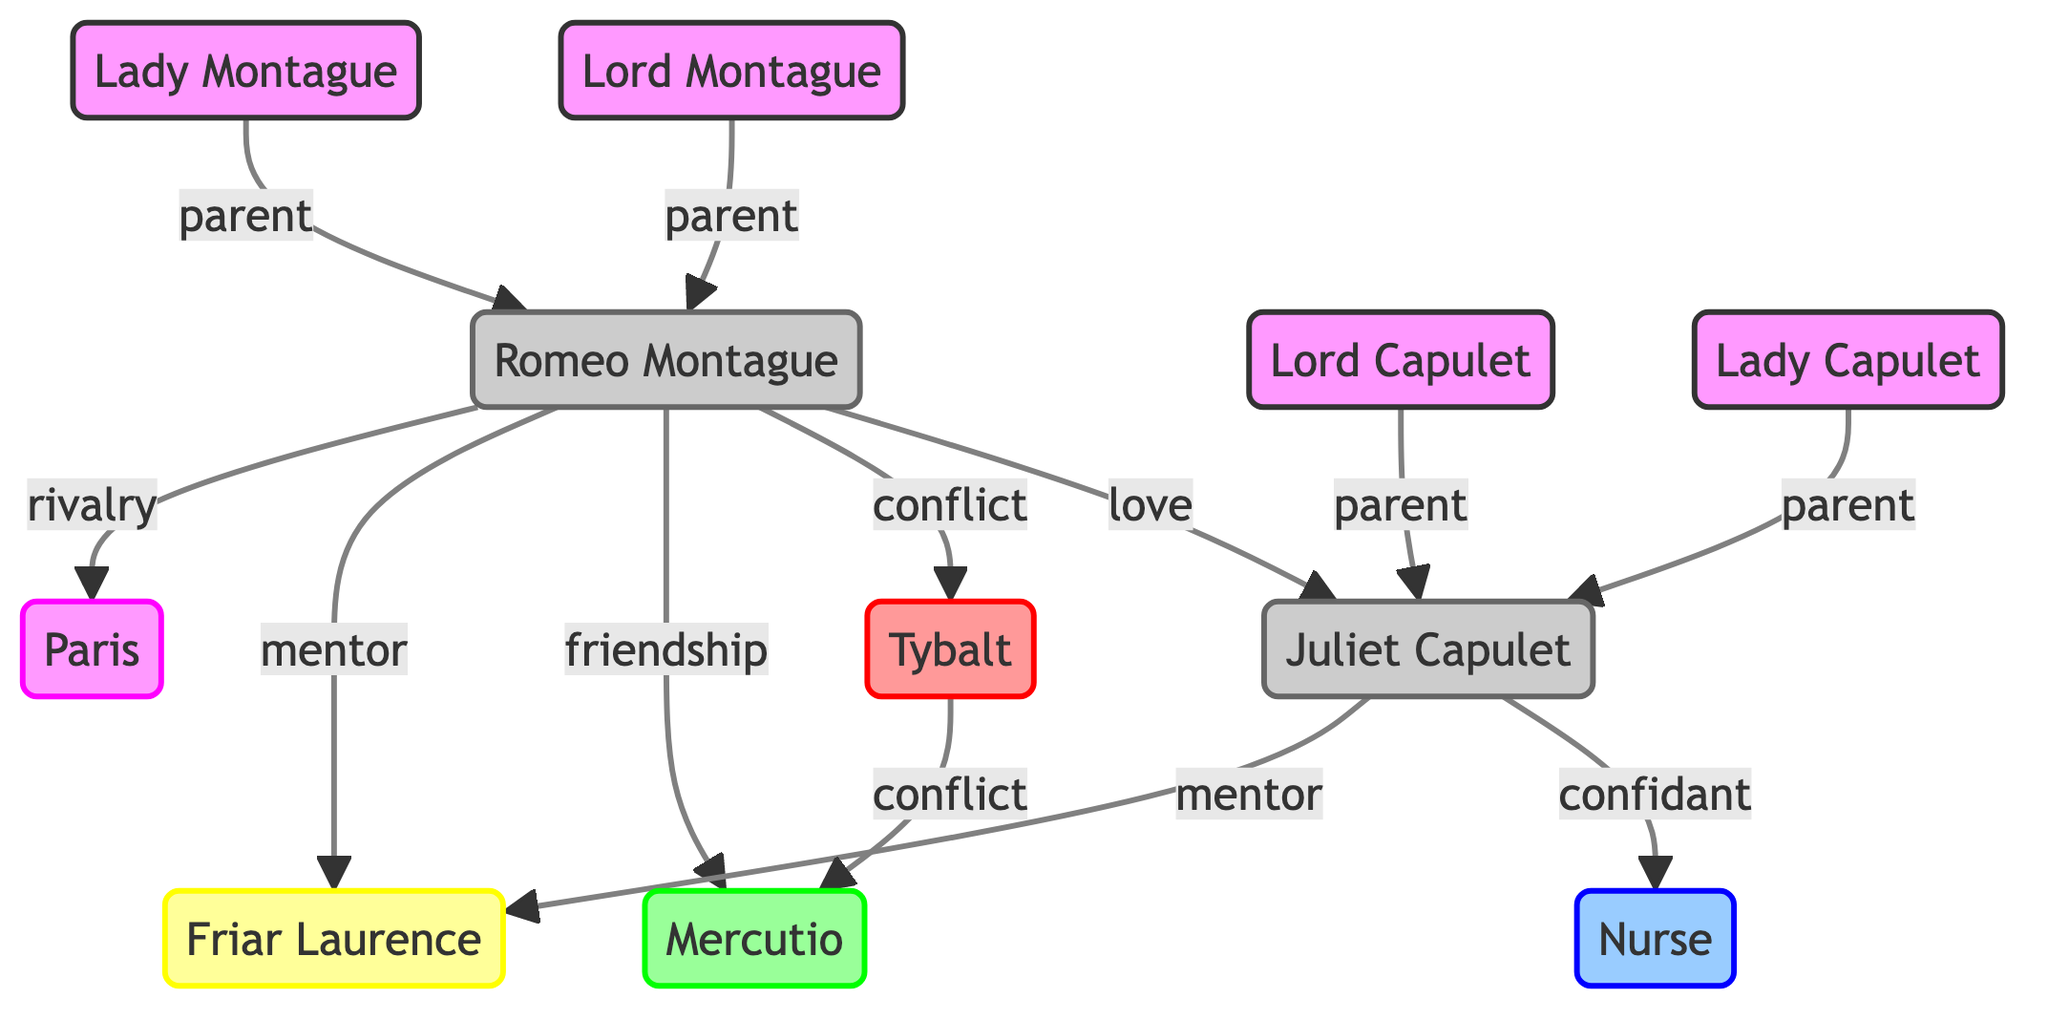What type of relationship exists between Romeo Montague and Juliet Capulet? The diagram indicates a "love" relationship between Romeo Montague and Juliet Capulet, denoted by an arrow connecting them labeled "love."
Answer: love How many characters are represented in the diagram? The diagram lists a total of 11 characters, which can be counted directly from the character nodes shown.
Answer: 11 Who acts as a mentor for both Romeo Montague and Juliet Capulet? The diagram shows an arrow leading from both Romeo Montague and Juliet Capulet to Friar Laurence, with the relationship type labeled as "mentor." This indicates he serves in this role for both characters.
Answer: Friar Laurence What type of connection does Tybalt have with Mercutio? There is a directed arrow from Tybalt to Mercutio labeled "conflict," which denotes the nature of their relationship as one of hostility.
Answer: conflict How many parent-child relationships are depicted in the diagram? The diagram displays four parent-child connections: two from Lord Capulet and Lady Capulet to Juliet Capulet and two from Lord Montague and Lady Montague to Romeo Montague, making a total of four parent-child relationships.
Answer: 4 Which character is in a rivalry with Romeo Montague? The diagram indicates a "rivalry" relationship with Paris, as shown by the directed arrow from Romeo Montague to Paris labeled "rivalry."
Answer: Paris Which character serves as a confidant to Juliet Capulet? The diagram shows that Juliet Capulet has a directed connection to the Nurse, labeled as "confidant." This indicates the Nurse plays this role in Juliet's life.
Answer: Nurse What are the two types of conflicts involving Tybalt? The diagram indicates Tybalt has conflicts with Romeo Montague and Mercutio, shown by directed arrows labeled "conflict" leading to both individuals from Tybalt.
Answer: Romeo Montague and Mercutio Which characters share a parent-child relationship on Juliet's side? The diagram displays two directed connections leading from both Lord Capulet and Lady Capulet to Juliet Capulet, indicating they share a parent-child relationship.
Answer: Lord Capulet and Lady Capulet 